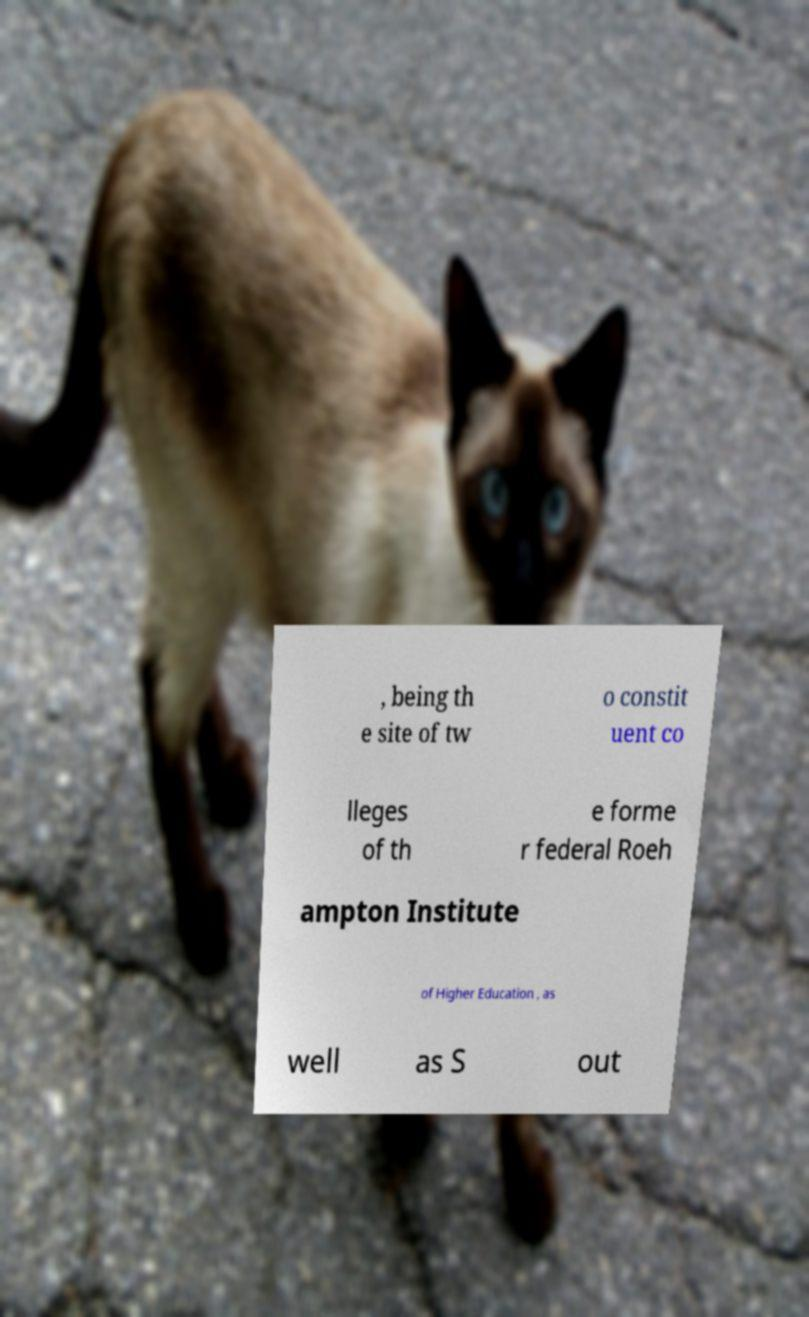Please read and relay the text visible in this image. What does it say? , being th e site of tw o constit uent co lleges of th e forme r federal Roeh ampton Institute of Higher Education , as well as S out 